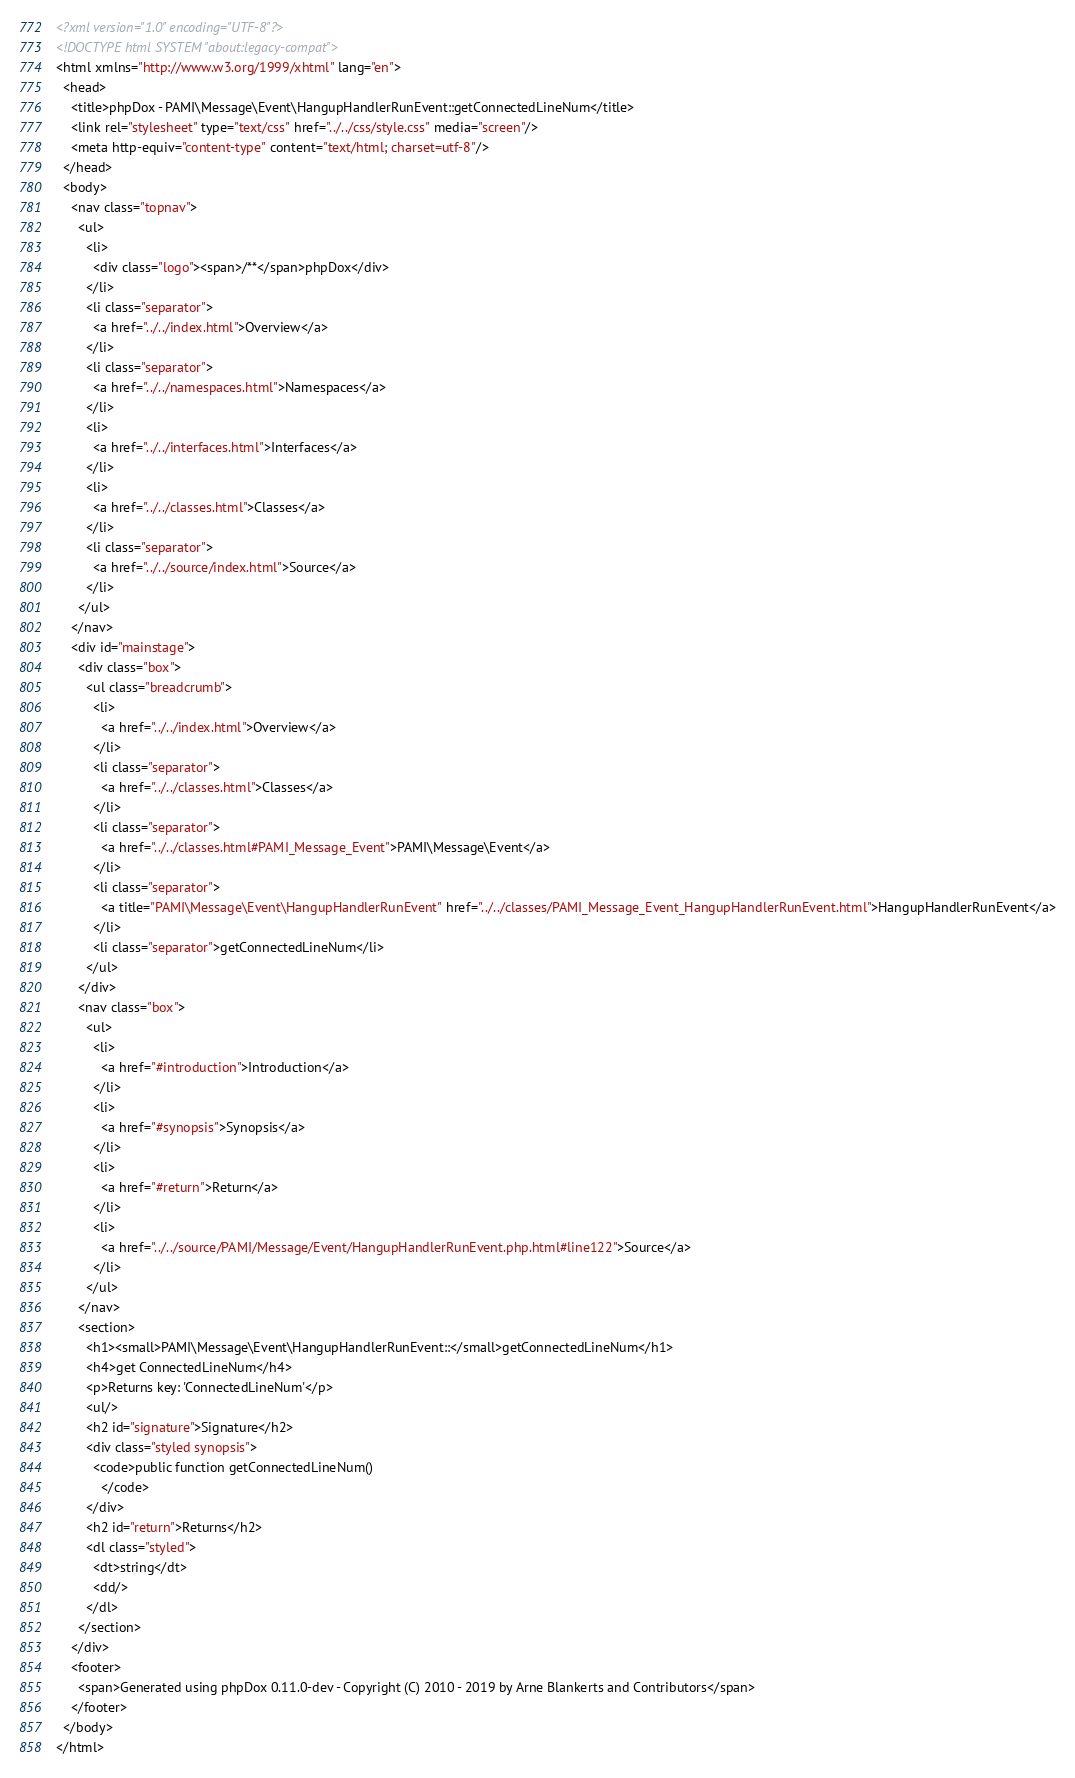<code> <loc_0><loc_0><loc_500><loc_500><_HTML_><?xml version="1.0" encoding="UTF-8"?>
<!DOCTYPE html SYSTEM "about:legacy-compat">
<html xmlns="http://www.w3.org/1999/xhtml" lang="en">
  <head>
    <title>phpDox - PAMI\Message\Event\HangupHandlerRunEvent::getConnectedLineNum</title>
    <link rel="stylesheet" type="text/css" href="../../css/style.css" media="screen"/>
    <meta http-equiv="content-type" content="text/html; charset=utf-8"/>
  </head>
  <body>
    <nav class="topnav">
      <ul>
        <li>
          <div class="logo"><span>/**</span>phpDox</div>
        </li>
        <li class="separator">
          <a href="../../index.html">Overview</a>
        </li>
        <li class="separator">
          <a href="../../namespaces.html">Namespaces</a>
        </li>
        <li>
          <a href="../../interfaces.html">Interfaces</a>
        </li>
        <li>
          <a href="../../classes.html">Classes</a>
        </li>
        <li class="separator">
          <a href="../../source/index.html">Source</a>
        </li>
      </ul>
    </nav>
    <div id="mainstage">
      <div class="box">
        <ul class="breadcrumb">
          <li>
            <a href="../../index.html">Overview</a>
          </li>
          <li class="separator">
            <a href="../../classes.html">Classes</a>
          </li>
          <li class="separator">
            <a href="../../classes.html#PAMI_Message_Event">PAMI\Message\Event</a>
          </li>
          <li class="separator">
            <a title="PAMI\Message\Event\HangupHandlerRunEvent" href="../../classes/PAMI_Message_Event_HangupHandlerRunEvent.html">HangupHandlerRunEvent</a>
          </li>
          <li class="separator">getConnectedLineNum</li>
        </ul>
      </div>
      <nav class="box">
        <ul>
          <li>
            <a href="#introduction">Introduction</a>
          </li>
          <li>
            <a href="#synopsis">Synopsis</a>
          </li>
          <li>
            <a href="#return">Return</a>
          </li>
          <li>
            <a href="../../source/PAMI/Message/Event/HangupHandlerRunEvent.php.html#line122">Source</a>
          </li>
        </ul>
      </nav>
      <section>
        <h1><small>PAMI\Message\Event\HangupHandlerRunEvent::</small>getConnectedLineNum</h1>
        <h4>get ConnectedLineNum</h4>
        <p>Returns key: 'ConnectedLineNum'</p>
        <ul/>
        <h2 id="signature">Signature</h2>
        <div class="styled synopsis">
          <code>public function getConnectedLineNum()
            </code>
        </div>
        <h2 id="return">Returns</h2>
        <dl class="styled">
          <dt>string</dt>
          <dd/>
        </dl>
      </section>
    </div>
    <footer>
      <span>Generated using phpDox 0.11.0-dev - Copyright (C) 2010 - 2019 by Arne Blankerts and Contributors</span>
    </footer>
  </body>
</html>
</code> 